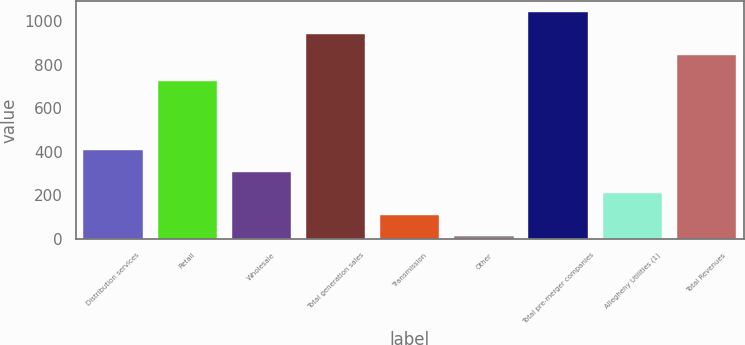<chart> <loc_0><loc_0><loc_500><loc_500><bar_chart><fcel>Distribution services<fcel>Retail<fcel>Wholesale<fcel>Total generation sales<fcel>Transmission<fcel>Other<fcel>Total pre-merger companies<fcel>Allegheny Utilities (1)<fcel>Total Revenues<nl><fcel>407<fcel>726<fcel>308.5<fcel>941.5<fcel>111.5<fcel>13<fcel>1040<fcel>210<fcel>843<nl></chart> 